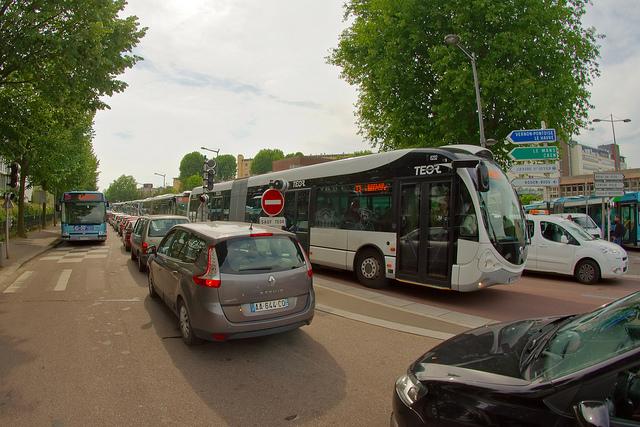What direction are the majority of cars?
Give a very brief answer. Away. What do the white lines indicate?
Be succinct. Lanes. What is blowing out of this van?
Keep it brief. Smoke. What kind of pole is at the front of the building?
Concise answer only. Light. What is the name of this street?
Quick response, please. Can't read it. Is that a long bus or train?
Quick response, please. Bus. Is a balloon on the tree?
Be succinct. No. Is there a dog in this photo?
Quick response, please. No. 